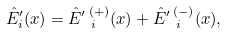Convert formula to latex. <formula><loc_0><loc_0><loc_500><loc_500>\hat { E } ^ { \prime } _ { i } ( x ) = \hat { E } ^ { \prime } \, _ { \, i } ^ { ( + ) } ( x ) + \hat { E } ^ { \prime } \, _ { \, i } ^ { ( - ) } ( x ) ,</formula> 